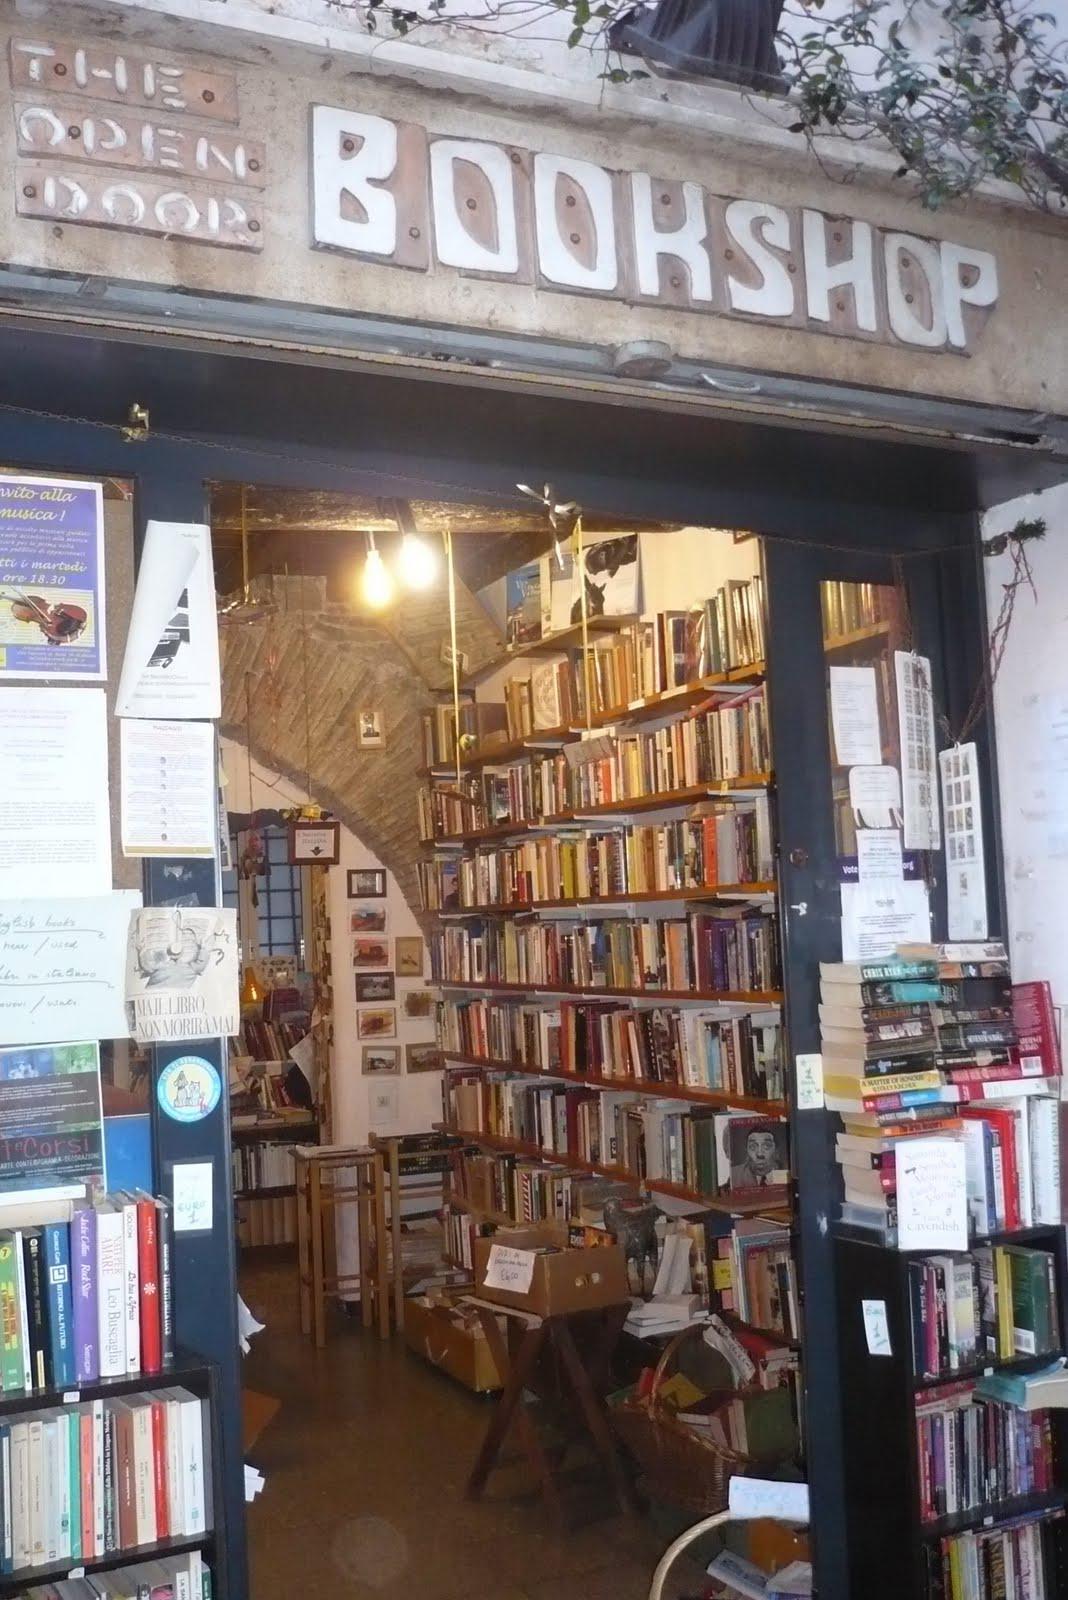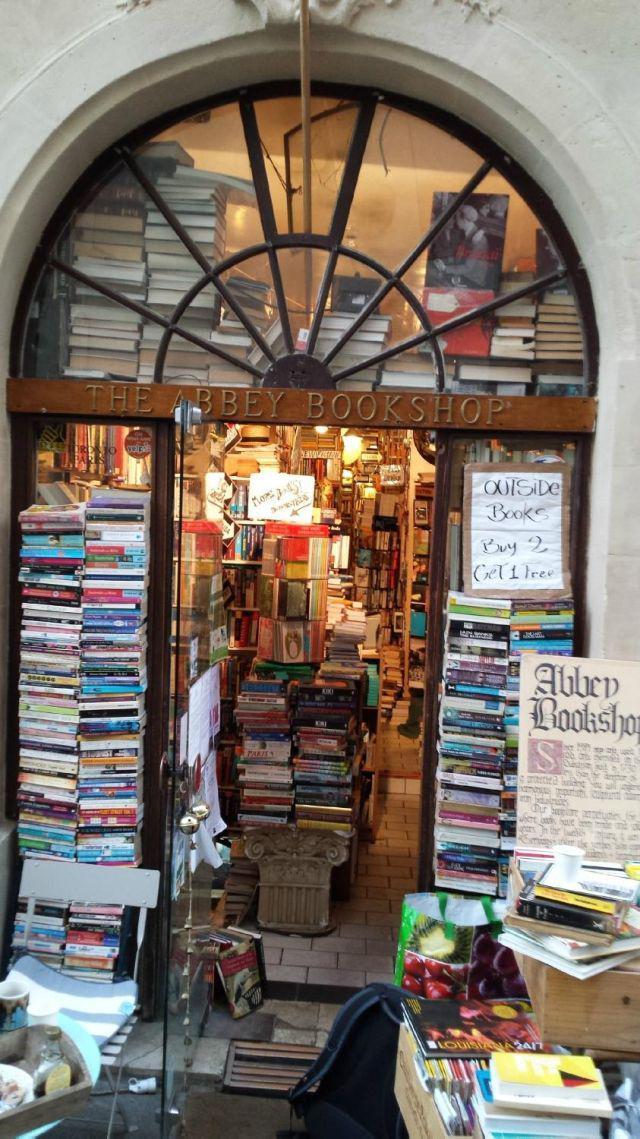The first image is the image on the left, the second image is the image on the right. For the images displayed, is the sentence "A form of seating is shown outside of a bookstore." factually correct? Answer yes or no. No. 